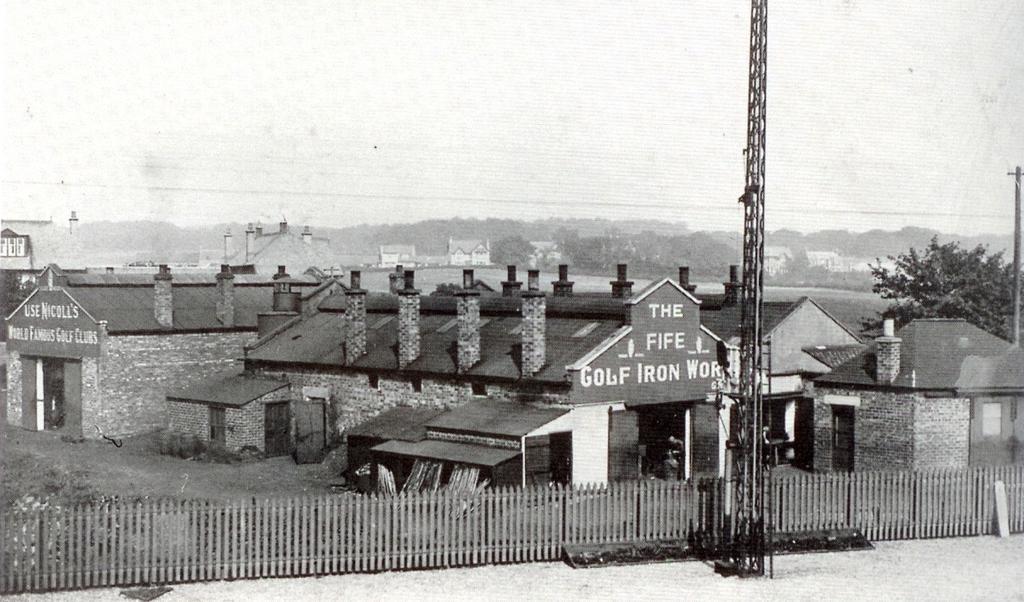Can you describe this image briefly? In this image, we can see sheds, poles, trees and there is a fence. 